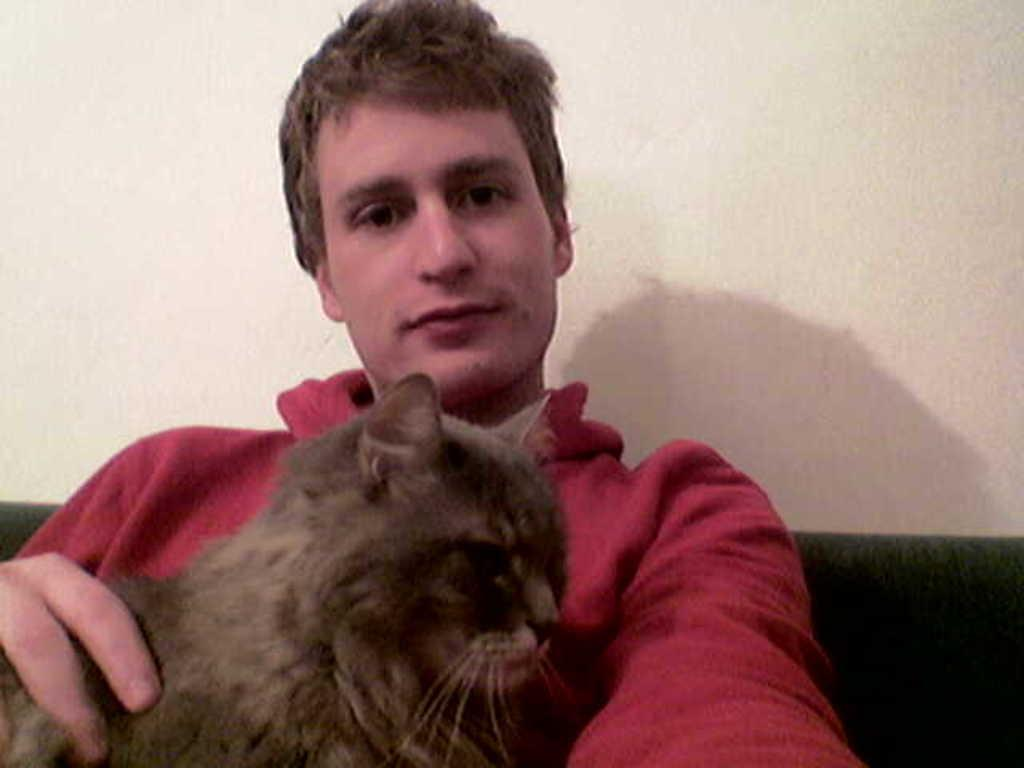Who is present in the image? There is a man in the image. What is the man doing in the image? The man is sitting on a sofa. What is the man holding in the image? The man is holding a cat in his hand. What type of cactus is on the table next to the man in the image? There is no cactus present in the image; the man is holding a cat in his hand. What is the man eating for breakfast in the image? The image does not show the man eating breakfast, nor is there any food visible. 